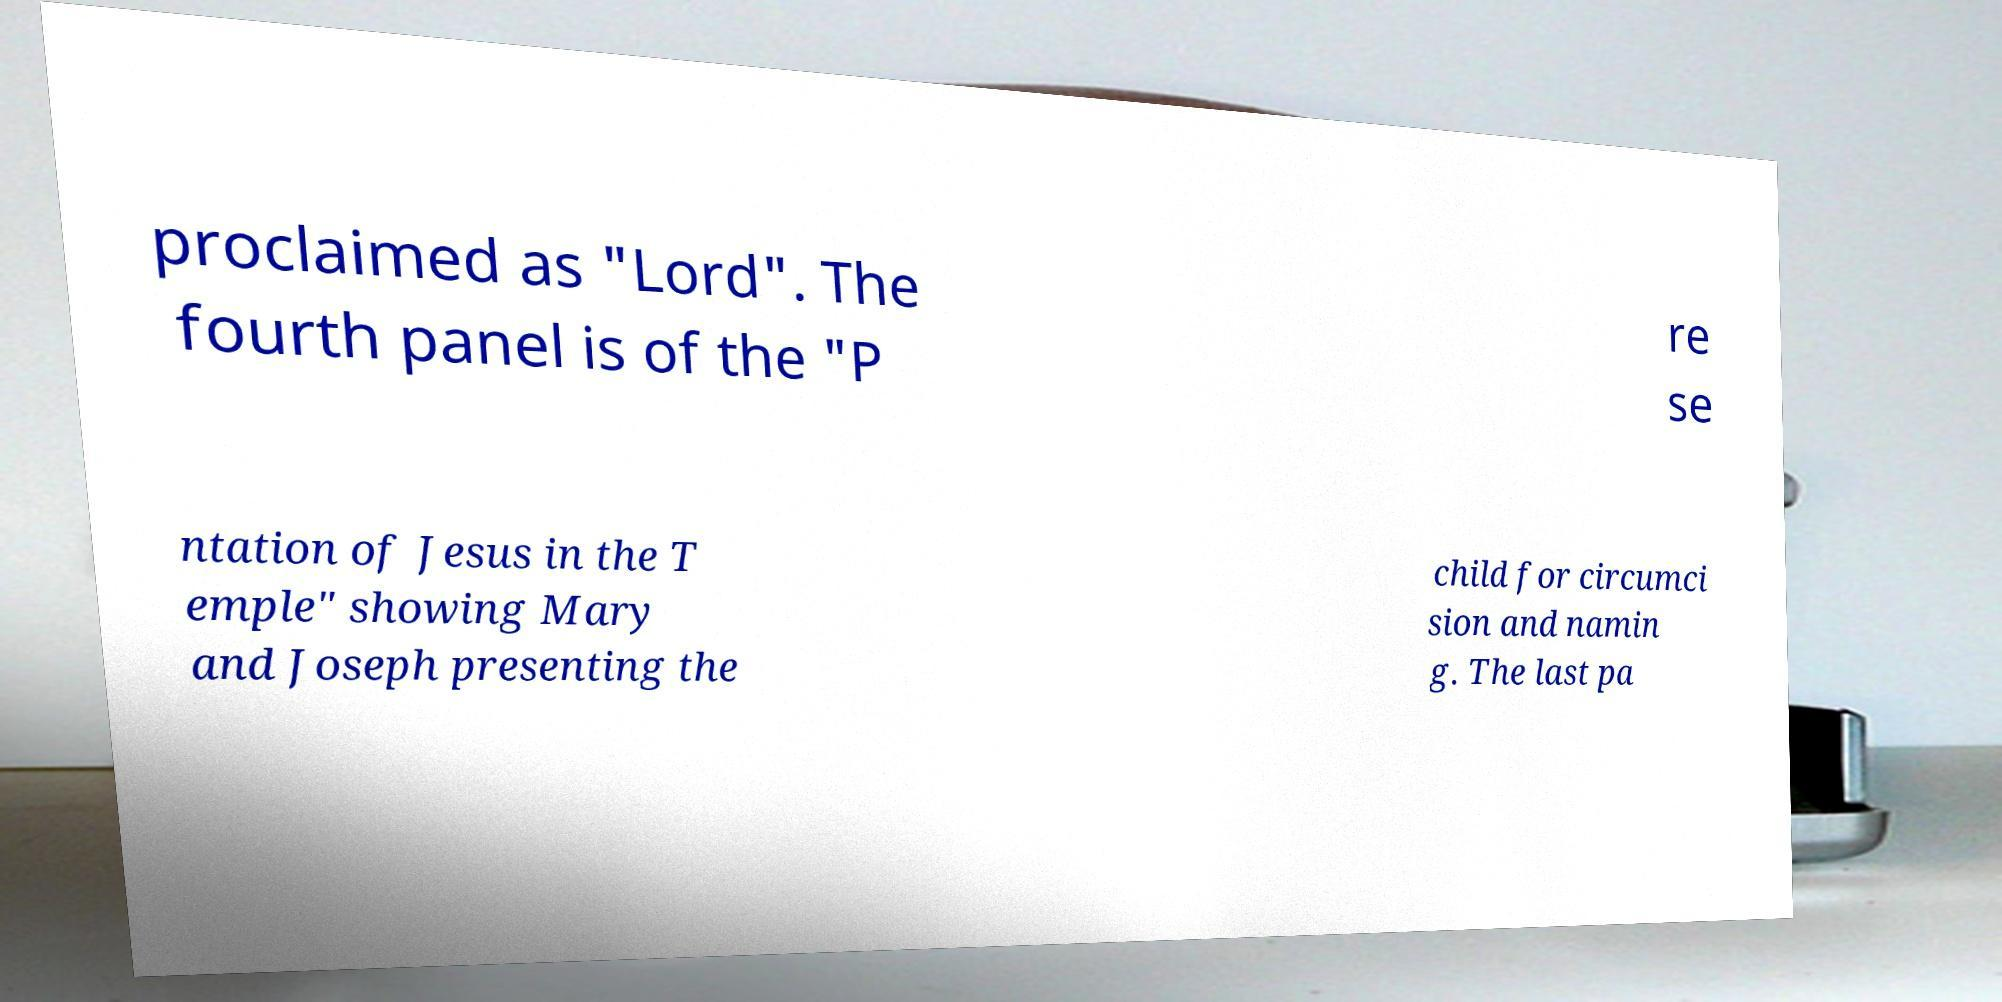There's text embedded in this image that I need extracted. Can you transcribe it verbatim? proclaimed as "Lord". The fourth panel is of the "P re se ntation of Jesus in the T emple" showing Mary and Joseph presenting the child for circumci sion and namin g. The last pa 